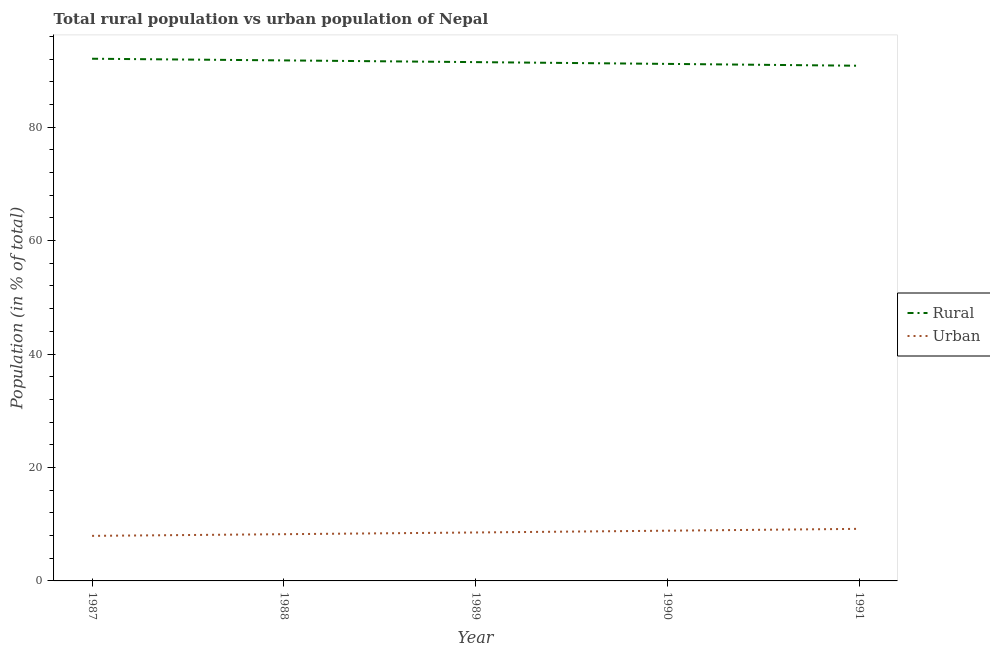How many different coloured lines are there?
Ensure brevity in your answer.  2. Does the line corresponding to rural population intersect with the line corresponding to urban population?
Give a very brief answer. No. Is the number of lines equal to the number of legend labels?
Your answer should be compact. Yes. What is the urban population in 1987?
Your response must be concise. 7.94. Across all years, what is the maximum urban population?
Give a very brief answer. 9.18. Across all years, what is the minimum rural population?
Provide a succinct answer. 90.82. In which year was the rural population minimum?
Offer a very short reply. 1991. What is the total urban population in the graph?
Your answer should be compact. 42.76. What is the difference between the rural population in 1989 and that in 1990?
Give a very brief answer. 0.31. What is the difference between the urban population in 1990 and the rural population in 1987?
Your answer should be compact. -83.2. What is the average rural population per year?
Provide a short and direct response. 91.45. In the year 1988, what is the difference between the rural population and urban population?
Offer a terse response. 83.52. What is the ratio of the urban population in 1987 to that in 1991?
Your response must be concise. 0.87. Is the urban population in 1989 less than that in 1990?
Offer a terse response. Yes. Is the difference between the urban population in 1987 and 1989 greater than the difference between the rural population in 1987 and 1989?
Your answer should be very brief. No. What is the difference between the highest and the second highest rural population?
Offer a very short reply. 0.29. What is the difference between the highest and the lowest rural population?
Provide a succinct answer. 1.24. In how many years, is the rural population greater than the average rural population taken over all years?
Offer a very short reply. 3. Is the urban population strictly greater than the rural population over the years?
Your response must be concise. No. How many lines are there?
Your answer should be compact. 2. How many years are there in the graph?
Give a very brief answer. 5. What is the difference between two consecutive major ticks on the Y-axis?
Provide a short and direct response. 20. Does the graph contain any zero values?
Provide a succinct answer. No. Does the graph contain grids?
Your response must be concise. No. How many legend labels are there?
Give a very brief answer. 2. What is the title of the graph?
Provide a succinct answer. Total rural population vs urban population of Nepal. What is the label or title of the X-axis?
Offer a terse response. Year. What is the label or title of the Y-axis?
Keep it short and to the point. Population (in % of total). What is the Population (in % of total) in Rural in 1987?
Your response must be concise. 92.06. What is the Population (in % of total) of Urban in 1987?
Your response must be concise. 7.94. What is the Population (in % of total) of Rural in 1988?
Your response must be concise. 91.76. What is the Population (in % of total) of Urban in 1988?
Make the answer very short. 8.24. What is the Population (in % of total) of Rural in 1989?
Ensure brevity in your answer.  91.46. What is the Population (in % of total) in Urban in 1989?
Your answer should be very brief. 8.54. What is the Population (in % of total) of Rural in 1990?
Provide a short and direct response. 91.15. What is the Population (in % of total) in Urban in 1990?
Your answer should be very brief. 8.85. What is the Population (in % of total) of Rural in 1991?
Offer a terse response. 90.82. What is the Population (in % of total) of Urban in 1991?
Your answer should be compact. 9.18. Across all years, what is the maximum Population (in % of total) in Rural?
Offer a very short reply. 92.06. Across all years, what is the maximum Population (in % of total) of Urban?
Your answer should be very brief. 9.18. Across all years, what is the minimum Population (in % of total) in Rural?
Make the answer very short. 90.82. Across all years, what is the minimum Population (in % of total) in Urban?
Keep it short and to the point. 7.94. What is the total Population (in % of total) in Rural in the graph?
Ensure brevity in your answer.  457.24. What is the total Population (in % of total) of Urban in the graph?
Provide a succinct answer. 42.76. What is the difference between the Population (in % of total) of Rural in 1987 and that in 1988?
Offer a very short reply. 0.29. What is the difference between the Population (in % of total) in Urban in 1987 and that in 1988?
Your response must be concise. -0.29. What is the difference between the Population (in % of total) in Rural in 1987 and that in 1989?
Give a very brief answer. 0.6. What is the difference between the Population (in % of total) in Urban in 1987 and that in 1989?
Ensure brevity in your answer.  -0.6. What is the difference between the Population (in % of total) of Rural in 1987 and that in 1990?
Provide a succinct answer. 0.91. What is the difference between the Population (in % of total) of Urban in 1987 and that in 1990?
Your answer should be compact. -0.91. What is the difference between the Population (in % of total) of Rural in 1987 and that in 1991?
Offer a terse response. 1.24. What is the difference between the Population (in % of total) of Urban in 1987 and that in 1991?
Make the answer very short. -1.24. What is the difference between the Population (in % of total) in Rural in 1988 and that in 1989?
Your answer should be very brief. 0.3. What is the difference between the Population (in % of total) in Urban in 1988 and that in 1989?
Provide a succinct answer. -0.3. What is the difference between the Population (in % of total) in Rural in 1988 and that in 1990?
Provide a succinct answer. 0.62. What is the difference between the Population (in % of total) of Urban in 1988 and that in 1990?
Your response must be concise. -0.62. What is the difference between the Population (in % of total) in Rural in 1988 and that in 1991?
Provide a short and direct response. 0.94. What is the difference between the Population (in % of total) in Urban in 1988 and that in 1991?
Offer a very short reply. -0.94. What is the difference between the Population (in % of total) in Rural in 1989 and that in 1990?
Make the answer very short. 0.31. What is the difference between the Population (in % of total) in Urban in 1989 and that in 1990?
Your response must be concise. -0.31. What is the difference between the Population (in % of total) of Rural in 1989 and that in 1991?
Offer a very short reply. 0.64. What is the difference between the Population (in % of total) in Urban in 1989 and that in 1991?
Provide a succinct answer. -0.64. What is the difference between the Population (in % of total) of Rural in 1990 and that in 1991?
Make the answer very short. 0.33. What is the difference between the Population (in % of total) of Urban in 1990 and that in 1991?
Your answer should be very brief. -0.33. What is the difference between the Population (in % of total) of Rural in 1987 and the Population (in % of total) of Urban in 1988?
Your response must be concise. 83.82. What is the difference between the Population (in % of total) in Rural in 1987 and the Population (in % of total) in Urban in 1989?
Offer a terse response. 83.52. What is the difference between the Population (in % of total) in Rural in 1987 and the Population (in % of total) in Urban in 1990?
Provide a succinct answer. 83.2. What is the difference between the Population (in % of total) of Rural in 1987 and the Population (in % of total) of Urban in 1991?
Make the answer very short. 82.88. What is the difference between the Population (in % of total) of Rural in 1988 and the Population (in % of total) of Urban in 1989?
Give a very brief answer. 83.22. What is the difference between the Population (in % of total) of Rural in 1988 and the Population (in % of total) of Urban in 1990?
Make the answer very short. 82.91. What is the difference between the Population (in % of total) in Rural in 1988 and the Population (in % of total) in Urban in 1991?
Ensure brevity in your answer.  82.58. What is the difference between the Population (in % of total) of Rural in 1989 and the Population (in % of total) of Urban in 1990?
Your answer should be very brief. 82.61. What is the difference between the Population (in % of total) in Rural in 1989 and the Population (in % of total) in Urban in 1991?
Provide a short and direct response. 82.28. What is the difference between the Population (in % of total) in Rural in 1990 and the Population (in % of total) in Urban in 1991?
Give a very brief answer. 81.97. What is the average Population (in % of total) of Rural per year?
Keep it short and to the point. 91.45. What is the average Population (in % of total) of Urban per year?
Provide a succinct answer. 8.55. In the year 1987, what is the difference between the Population (in % of total) of Rural and Population (in % of total) of Urban?
Make the answer very short. 84.11. In the year 1988, what is the difference between the Population (in % of total) in Rural and Population (in % of total) in Urban?
Your answer should be very brief. 83.52. In the year 1989, what is the difference between the Population (in % of total) of Rural and Population (in % of total) of Urban?
Ensure brevity in your answer.  82.92. In the year 1990, what is the difference between the Population (in % of total) of Rural and Population (in % of total) of Urban?
Your response must be concise. 82.29. In the year 1991, what is the difference between the Population (in % of total) of Rural and Population (in % of total) of Urban?
Offer a very short reply. 81.64. What is the ratio of the Population (in % of total) in Urban in 1987 to that in 1989?
Your answer should be very brief. 0.93. What is the ratio of the Population (in % of total) in Urban in 1987 to that in 1990?
Ensure brevity in your answer.  0.9. What is the ratio of the Population (in % of total) of Rural in 1987 to that in 1991?
Make the answer very short. 1.01. What is the ratio of the Population (in % of total) of Urban in 1987 to that in 1991?
Your answer should be very brief. 0.87. What is the ratio of the Population (in % of total) in Rural in 1988 to that in 1989?
Offer a very short reply. 1. What is the ratio of the Population (in % of total) of Urban in 1988 to that in 1989?
Make the answer very short. 0.96. What is the ratio of the Population (in % of total) of Rural in 1988 to that in 1990?
Give a very brief answer. 1.01. What is the ratio of the Population (in % of total) in Urban in 1988 to that in 1990?
Keep it short and to the point. 0.93. What is the ratio of the Population (in % of total) of Rural in 1988 to that in 1991?
Offer a very short reply. 1.01. What is the ratio of the Population (in % of total) in Urban in 1988 to that in 1991?
Your answer should be very brief. 0.9. What is the ratio of the Population (in % of total) in Rural in 1989 to that in 1990?
Your answer should be very brief. 1. What is the ratio of the Population (in % of total) in Urban in 1989 to that in 1990?
Your answer should be very brief. 0.96. What is the ratio of the Population (in % of total) in Urban in 1989 to that in 1991?
Make the answer very short. 0.93. What is the ratio of the Population (in % of total) of Urban in 1990 to that in 1991?
Provide a short and direct response. 0.96. What is the difference between the highest and the second highest Population (in % of total) in Rural?
Your answer should be compact. 0.29. What is the difference between the highest and the second highest Population (in % of total) in Urban?
Your answer should be very brief. 0.33. What is the difference between the highest and the lowest Population (in % of total) of Rural?
Make the answer very short. 1.24. What is the difference between the highest and the lowest Population (in % of total) of Urban?
Your response must be concise. 1.24. 